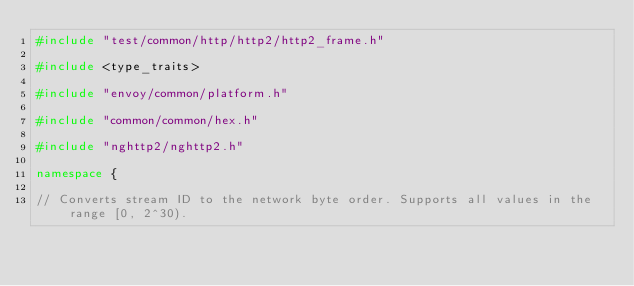<code> <loc_0><loc_0><loc_500><loc_500><_C++_>#include "test/common/http/http2/http2_frame.h"

#include <type_traits>

#include "envoy/common/platform.h"

#include "common/common/hex.h"

#include "nghttp2/nghttp2.h"

namespace {

// Converts stream ID to the network byte order. Supports all values in the range [0, 2^30).</code> 